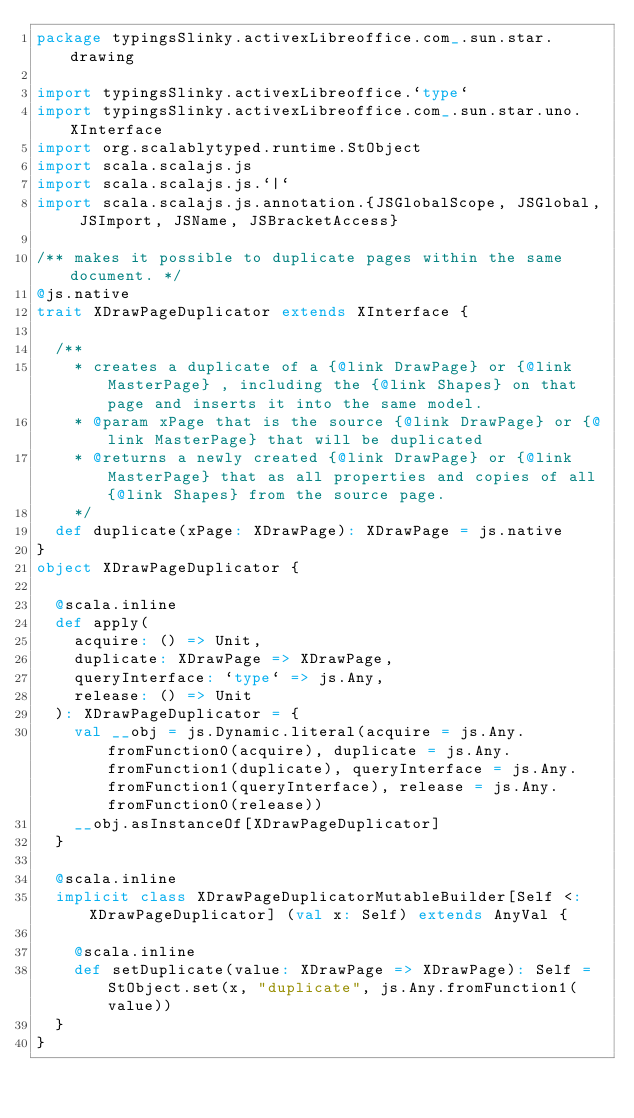<code> <loc_0><loc_0><loc_500><loc_500><_Scala_>package typingsSlinky.activexLibreoffice.com_.sun.star.drawing

import typingsSlinky.activexLibreoffice.`type`
import typingsSlinky.activexLibreoffice.com_.sun.star.uno.XInterface
import org.scalablytyped.runtime.StObject
import scala.scalajs.js
import scala.scalajs.js.`|`
import scala.scalajs.js.annotation.{JSGlobalScope, JSGlobal, JSImport, JSName, JSBracketAccess}

/** makes it possible to duplicate pages within the same document. */
@js.native
trait XDrawPageDuplicator extends XInterface {
  
  /**
    * creates a duplicate of a {@link DrawPage} or {@link MasterPage} , including the {@link Shapes} on that page and inserts it into the same model.
    * @param xPage that is the source {@link DrawPage} or {@link MasterPage} that will be duplicated
    * @returns a newly created {@link DrawPage} or {@link MasterPage} that as all properties and copies of all {@link Shapes} from the source page.
    */
  def duplicate(xPage: XDrawPage): XDrawPage = js.native
}
object XDrawPageDuplicator {
  
  @scala.inline
  def apply(
    acquire: () => Unit,
    duplicate: XDrawPage => XDrawPage,
    queryInterface: `type` => js.Any,
    release: () => Unit
  ): XDrawPageDuplicator = {
    val __obj = js.Dynamic.literal(acquire = js.Any.fromFunction0(acquire), duplicate = js.Any.fromFunction1(duplicate), queryInterface = js.Any.fromFunction1(queryInterface), release = js.Any.fromFunction0(release))
    __obj.asInstanceOf[XDrawPageDuplicator]
  }
  
  @scala.inline
  implicit class XDrawPageDuplicatorMutableBuilder[Self <: XDrawPageDuplicator] (val x: Self) extends AnyVal {
    
    @scala.inline
    def setDuplicate(value: XDrawPage => XDrawPage): Self = StObject.set(x, "duplicate", js.Any.fromFunction1(value))
  }
}
</code> 